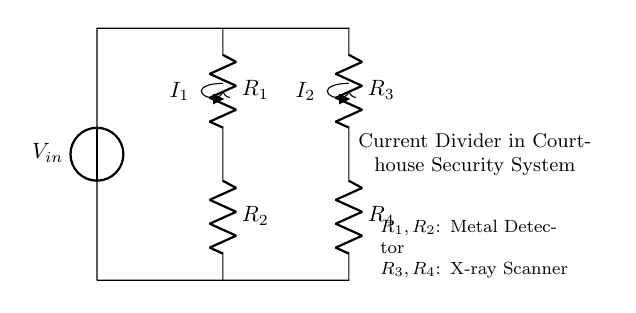What is the input voltage in this circuit? The input voltage \( V_{in} \) is indicated by the voltage source in the diagram, shown at the top of the circuit.
Answer: V_{in} What type of component are \( R_1 \) and \( R_2 \)? Both \( R_1 \) and \( R_2 \) are labeled as resistors in the circuit, which means they are components that resist the flow of current.
Answer: Resistors How many branches are there in the current divider circuit? The circuit shows two distinct paths for current: one through \( R_1 \) and \( R_2 \) and another through \( R_3 \) and \( R_4 \), indicating there are two branches of current.
Answer: Two What do the resistors \( R_3 \) and \( R_4 \) represent? \( R_3 \) and \( R_4 \) are described in the diagram as components for the X-ray scanner, indicating their role in the current divider circuit specifically in that context.
Answer: X-ray Scanner How does the current \( I_1 \) relate to \( I_2 \) in this circuit? In a current divider circuit, the current splitting between branches depends on the resistance values: higher resistance in one branch results in lower current compared to the branch with lower resistance. Therefore, the ratio of \( I_1 \) to \( I_2 \) is determined by the values of \( R_1, R_2, R_3, \) and \( R_4 \).
Answer: Inversely proportional What happens to the total current \( I \) in this current divider? The total current entering the circuit splits into \( I_1 \) and \( I_2 \) based on the resistance values; hence, the sum of the currents in both branches equals the total input current \( I \).
Answer: Total current splits 